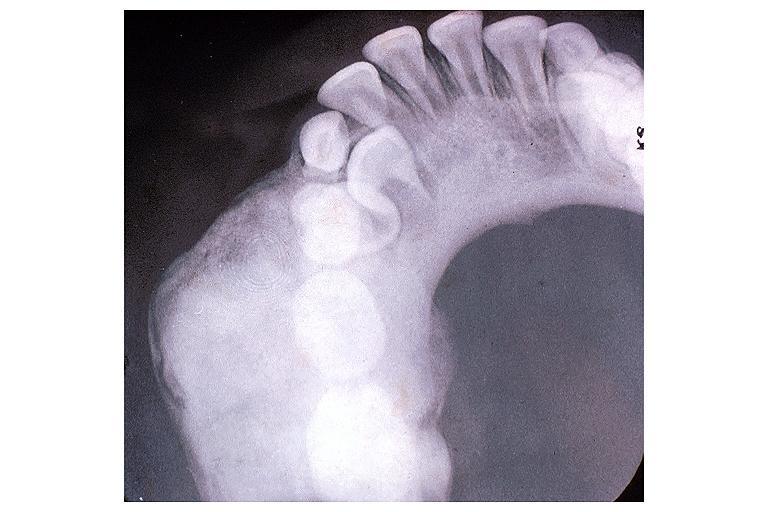what is present?
Answer the question using a single word or phrase. Oral 